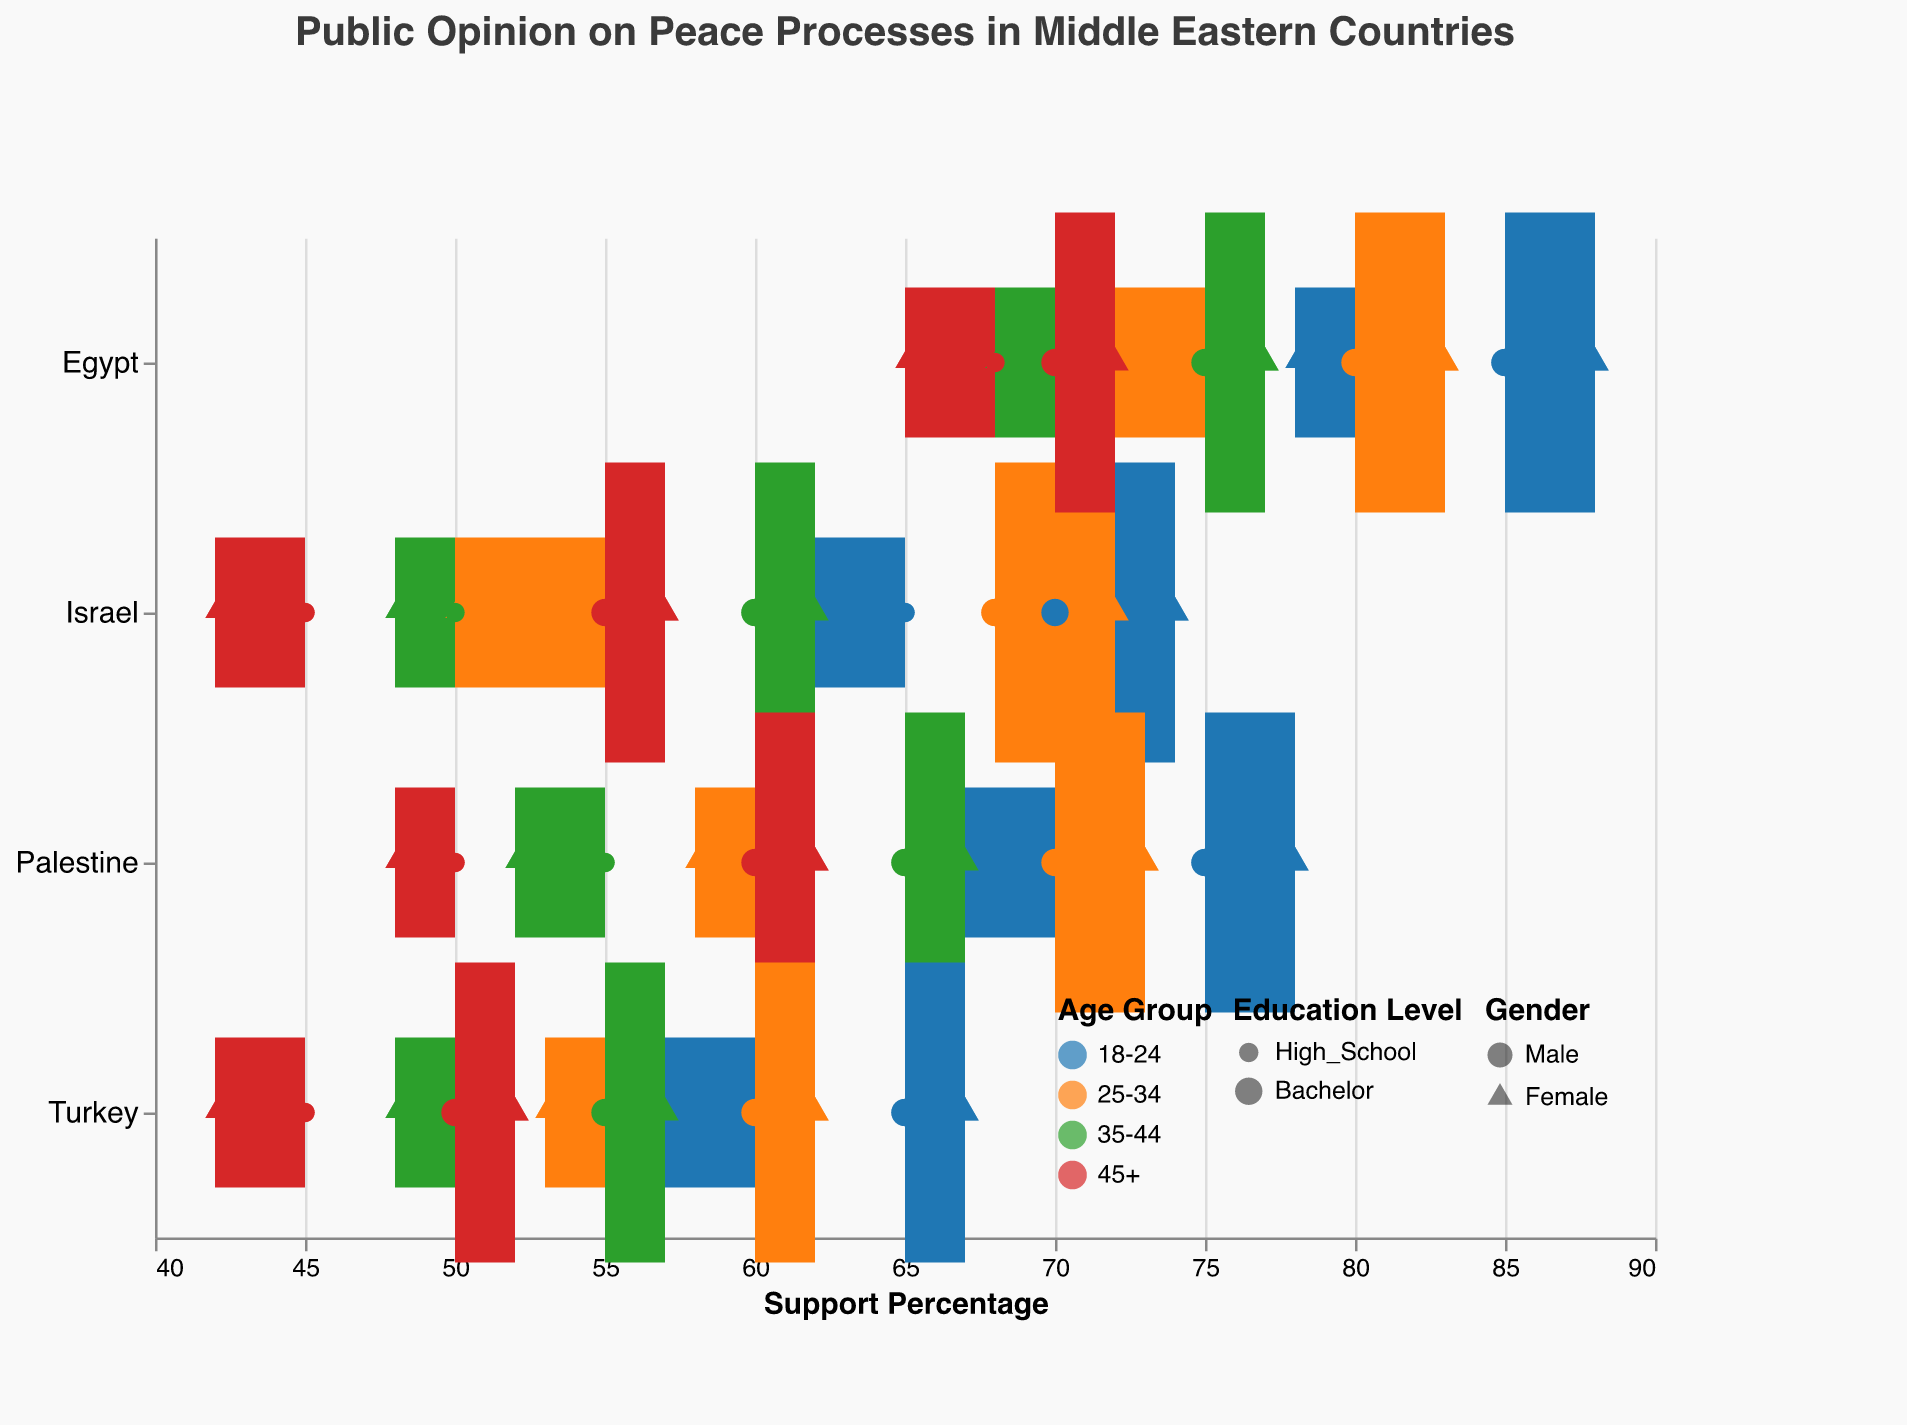What's the title of the chart? The title is located at the top of the visual representation, stating the overall subject of the analysis
Answer: Public Opinion on Peace Processes in Middle Eastern Countries What age group in Egypt has the highest support percentage for the peace process? Examine the color-coded age groups in Egypt and look for the dot with the highest value on the x-axis
Answer: 18-24 Compare the support percentages of 18-24 year-old males with a high school education in Israel and Palestine. Which is higher? Locate the shapes corresponding to 18-24 year-old males with a high school education in both countries and compare the values on the x-axis
Answer: Palestine (70%) is higher than Israel (65%) Which age group shows the least support for peace processes in Turkey? Identify the age group color that appears closest to the lower end of the support percentage axis
Answer: 45+ Among females with a bachelor's degree, which country shows the highest support percentage for the peace processes? Isolate the triangles indicating females with a bachelor's degree and compare their positions on the x-axis across countries
Answer: Egypt (88%) What is the support percentage range for 25-34 year-olds in Palestine? Observe the range line defined by the highest and lowest support percentages for 25-34 year-olds in Palestine
Answer: 58 to 73 What is the difference in support percentages between 25-34 year-old males and females with high school education in Israel? Subtract the support percentage of 25-34 year-old females from 25-34 year-old males with high school education in Israel
Answer: 55 - 50 = 5% Which country has the smallest range in support percentages by demographics? Compare the lengths of the range lines across all countries to find the shortest
Answer: Israel (42 to 74) How does the support for peace processes among 35-44 year-olds with high school education in Egypt compare to those in Turkey? Examine the shapes for 35-44 year-olds with high school education in both countries and compare the x-axis values
Answer: Egypt (70) > Turkey (50) What's the average support percentage for 45+ year-olds with bachelor's degrees in all listed countries? Add the support percentages for 45+ year-olds with bachelor's degrees in all countries and divide by the number of data points (4 countries)
Answer: (55+57+60+62+70+72+50+52)/8 = 59.75 